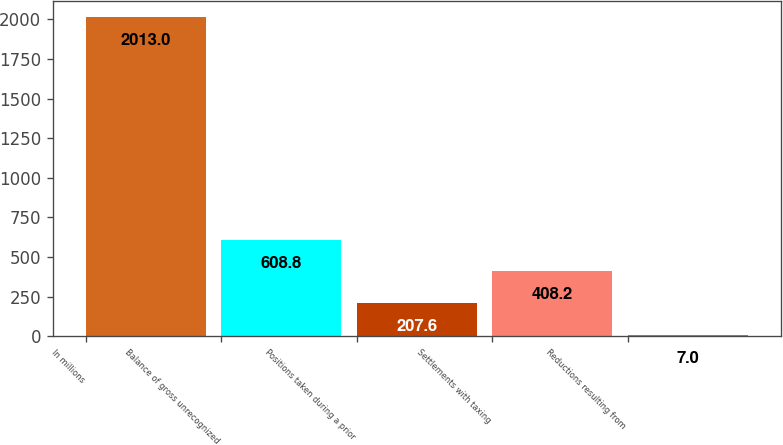Convert chart. <chart><loc_0><loc_0><loc_500><loc_500><bar_chart><fcel>In millions<fcel>Balance of gross unrecognized<fcel>Positions taken during a prior<fcel>Settlements with taxing<fcel>Reductions resulting from<nl><fcel>2013<fcel>608.8<fcel>207.6<fcel>408.2<fcel>7<nl></chart> 